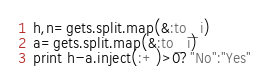<code> <loc_0><loc_0><loc_500><loc_500><_Ruby_>h,n=gets.split.map(&:to_i)
a=gets.split.map(&:to_i)
print h-a.inject(:+)>0?"No":"Yes"

</code> 